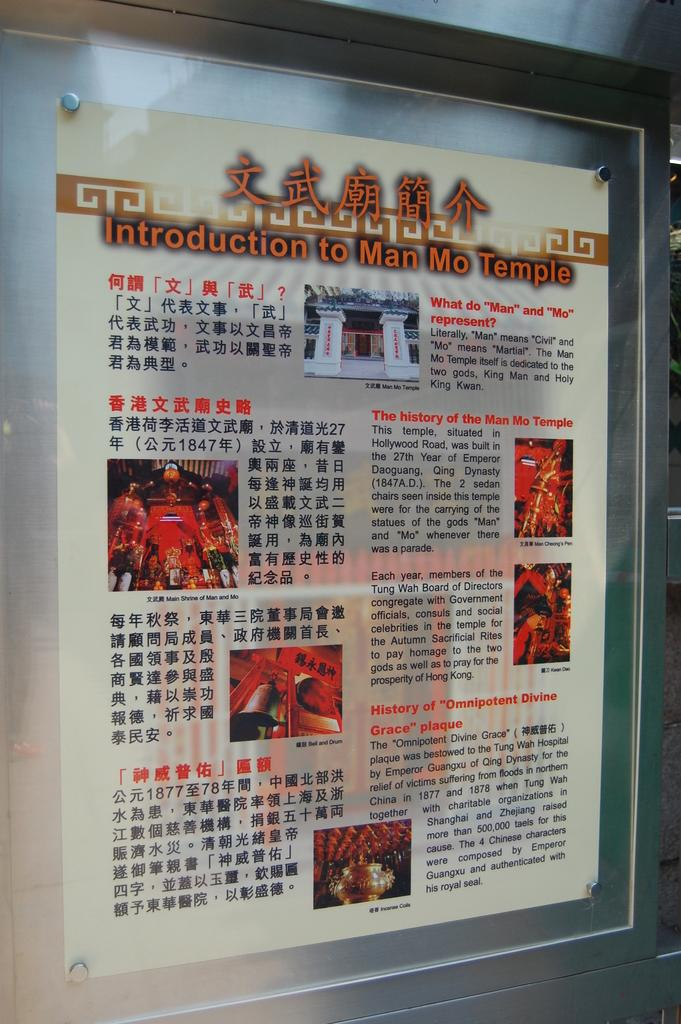<image>
Give a short and clear explanation of the subsequent image. Paper framed on a wall that says Introduction to Man Mo Temple. 